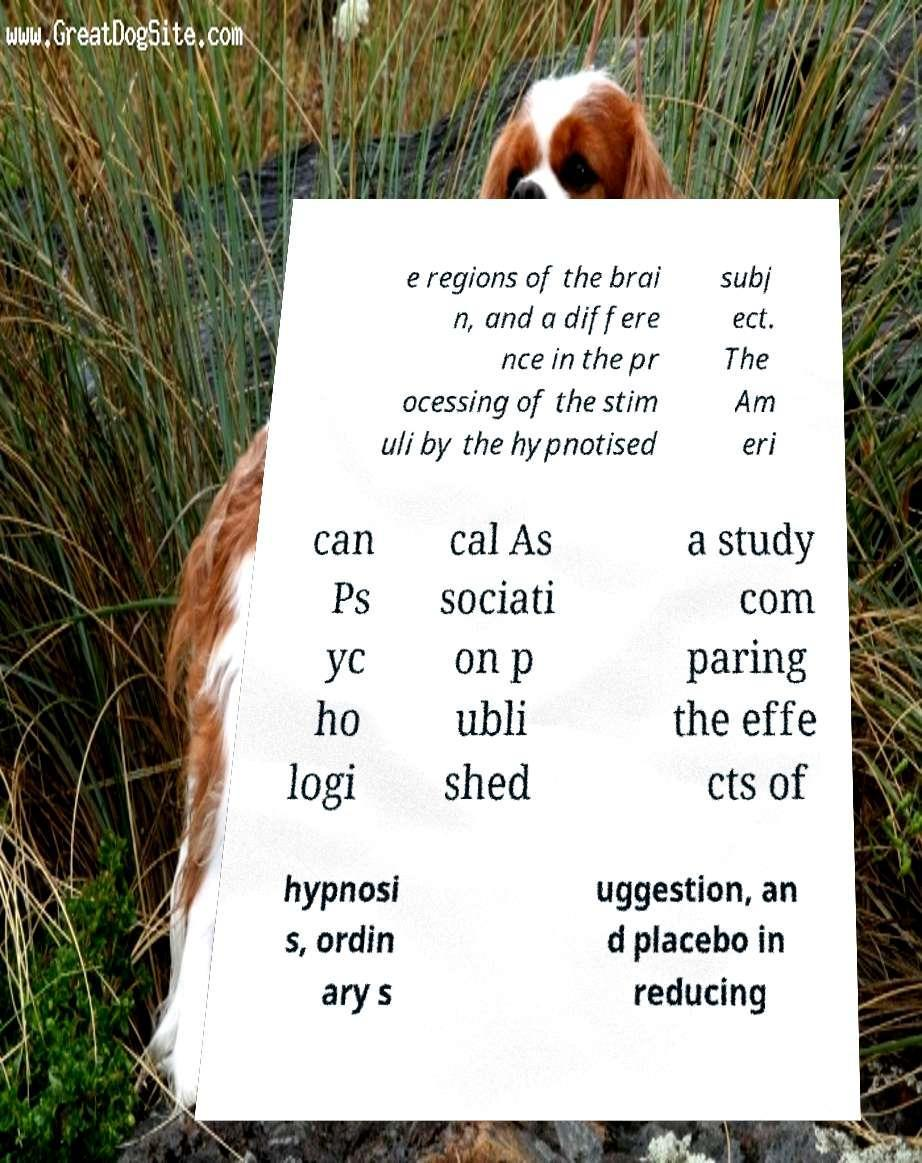Could you extract and type out the text from this image? e regions of the brai n, and a differe nce in the pr ocessing of the stim uli by the hypnotised subj ect. The Am eri can Ps yc ho logi cal As sociati on p ubli shed a study com paring the effe cts of hypnosi s, ordin ary s uggestion, an d placebo in reducing 